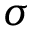Convert formula to latex. <formula><loc_0><loc_0><loc_500><loc_500>\sigma</formula> 